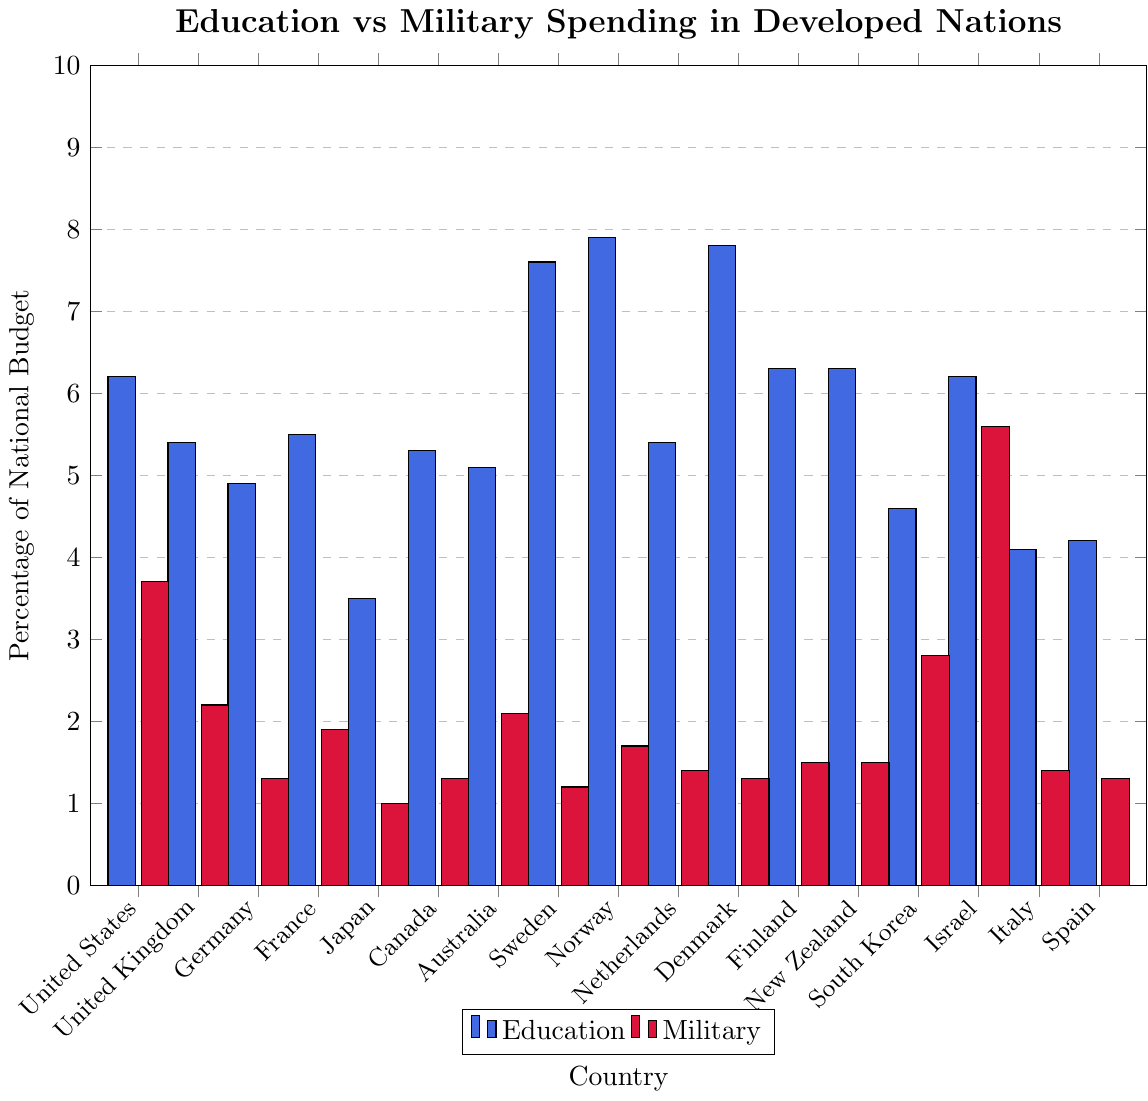Which country allocates the highest percentage of its national budget to education? The highest bar in the education category reflects the country with the biggest percentage allocation. Looking at the bars colored in blue for education, Norway has the tallest bar, showing 7.9%.
Answer: Norway Which country has the largest gap between education and military spending? To determine the largest gap, we need to assess the difference between the height of the blue bar (education) and the red bar (military) for each country. Israel's blue bar (6.2%) and red bar (5.6%) have a difference of 0.6%, which is greater than the differences for other countries' corresponding bars.
Answer: Israel What is the average percentage of the national budget allocated to education for the countries shown? Sum all education percentages and divide by the number of countries. (6.2+5.4+4.9+5.5+3.5+5.3+5.1+7.6+7.9+5.4+7.8+6.3+6.3+4.6+6.2+4.1+4.2) / 17 = 5.6%
Answer: 5.6% Which countries allocate more than twice as much of their national budget to education compared to military spending? We need to identify the countries where the height of the blue bar (education) is more than twice the height of the red bar (military). Norway (7.9% vs. 1.7%), Sweden (7.6% vs. 1.2%), Denmark (7.8% vs. 1.3%), Germany (4.9% vs. 1.3%), Finland (6.3% vs. 1.5%), New Zealand (6.3% vs. 1.5%), and the Netherlands (5.4% vs. 1.4%) all satisfy this condition.
Answer: Norway, Sweden, Denmark, Germany, Finland, New Zealand, Netherlands How does South Korea's military spending compare to that of the United States? Compare the height of South Korea's red bar (2.8%) to that of the United States (3.7%). 2.8% is less than 3.7%.
Answer: Less What is the combined percentage of the national budget allocated to education for Sweden, Norway, and Denmark? Add the education budget percentages of Sweden (7.6%), Norway (7.9%), and Denmark (7.8%). 7.6% + 7.9% + 7.8% = 23.3%
Answer: 23.3% Is the percentage of the national budget allocated to military spending in Japan greater or less than in Italy? Compare the heights of the red bars for Japan (1.0%) and Italy (1.4%). 1.0% is less than 1.4%.
Answer: Less Which three countries have the lowest education spending and what are their percentages? Identify the three shortest blue bars. Japan (3.5%), Spain (4.2%), and Italy (4.1%) have the lowest percentages.
Answer: Japan, Spain, Italy (3.5%, 4.2%, 4.1%) What is the difference in the total percentage of the national budgets allocated to military spending between the United States and France? Subtract France’s military spending percentage (1.9%) from the United States’ (3.7%). 3.7% - 1.9% = 1.8%
Answer: 1.8% Which country has the smallest percentage of its budget allocated to military spending, and what is the value? The smallest red bar indicates the country with the lowest military spending. Japan, with a red bar representing 1.0%, has the lowest value.
Answer: Japan (1.0%) 